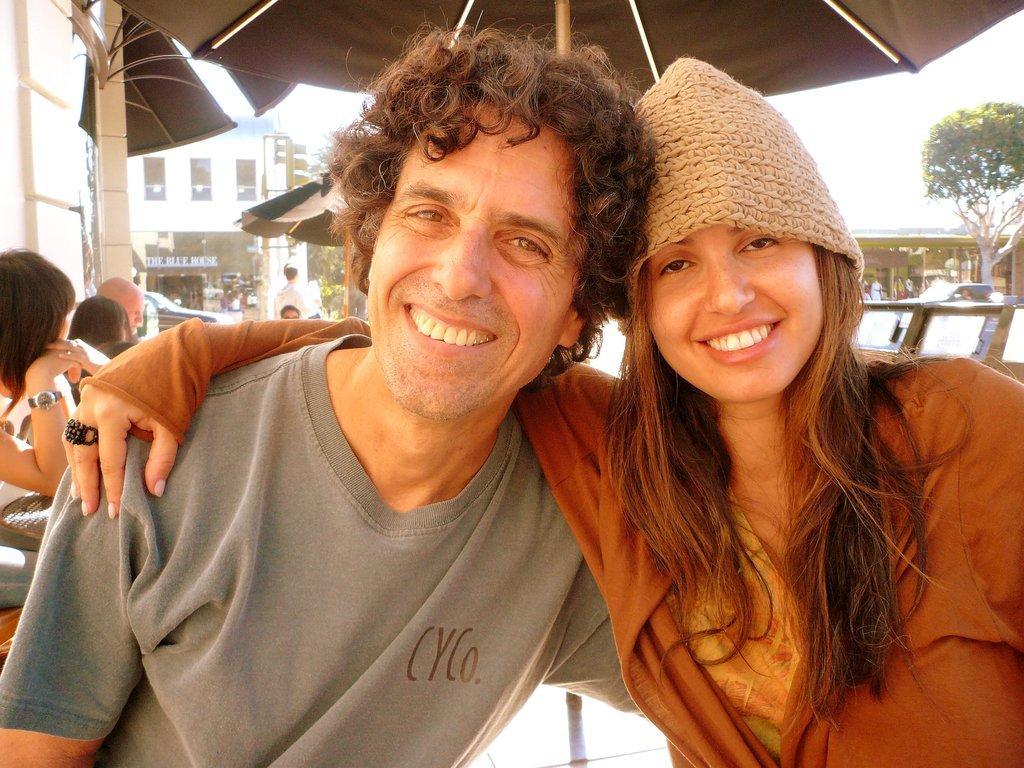Could you give a brief overview of what you see in this image? In this picture we can see a building, board, people, trees and few objects. We can see a man and a woman is wearing a cap. They both are smiling and giving a pose. At the top portion of the picture we can see the partial part of an umbrella. 